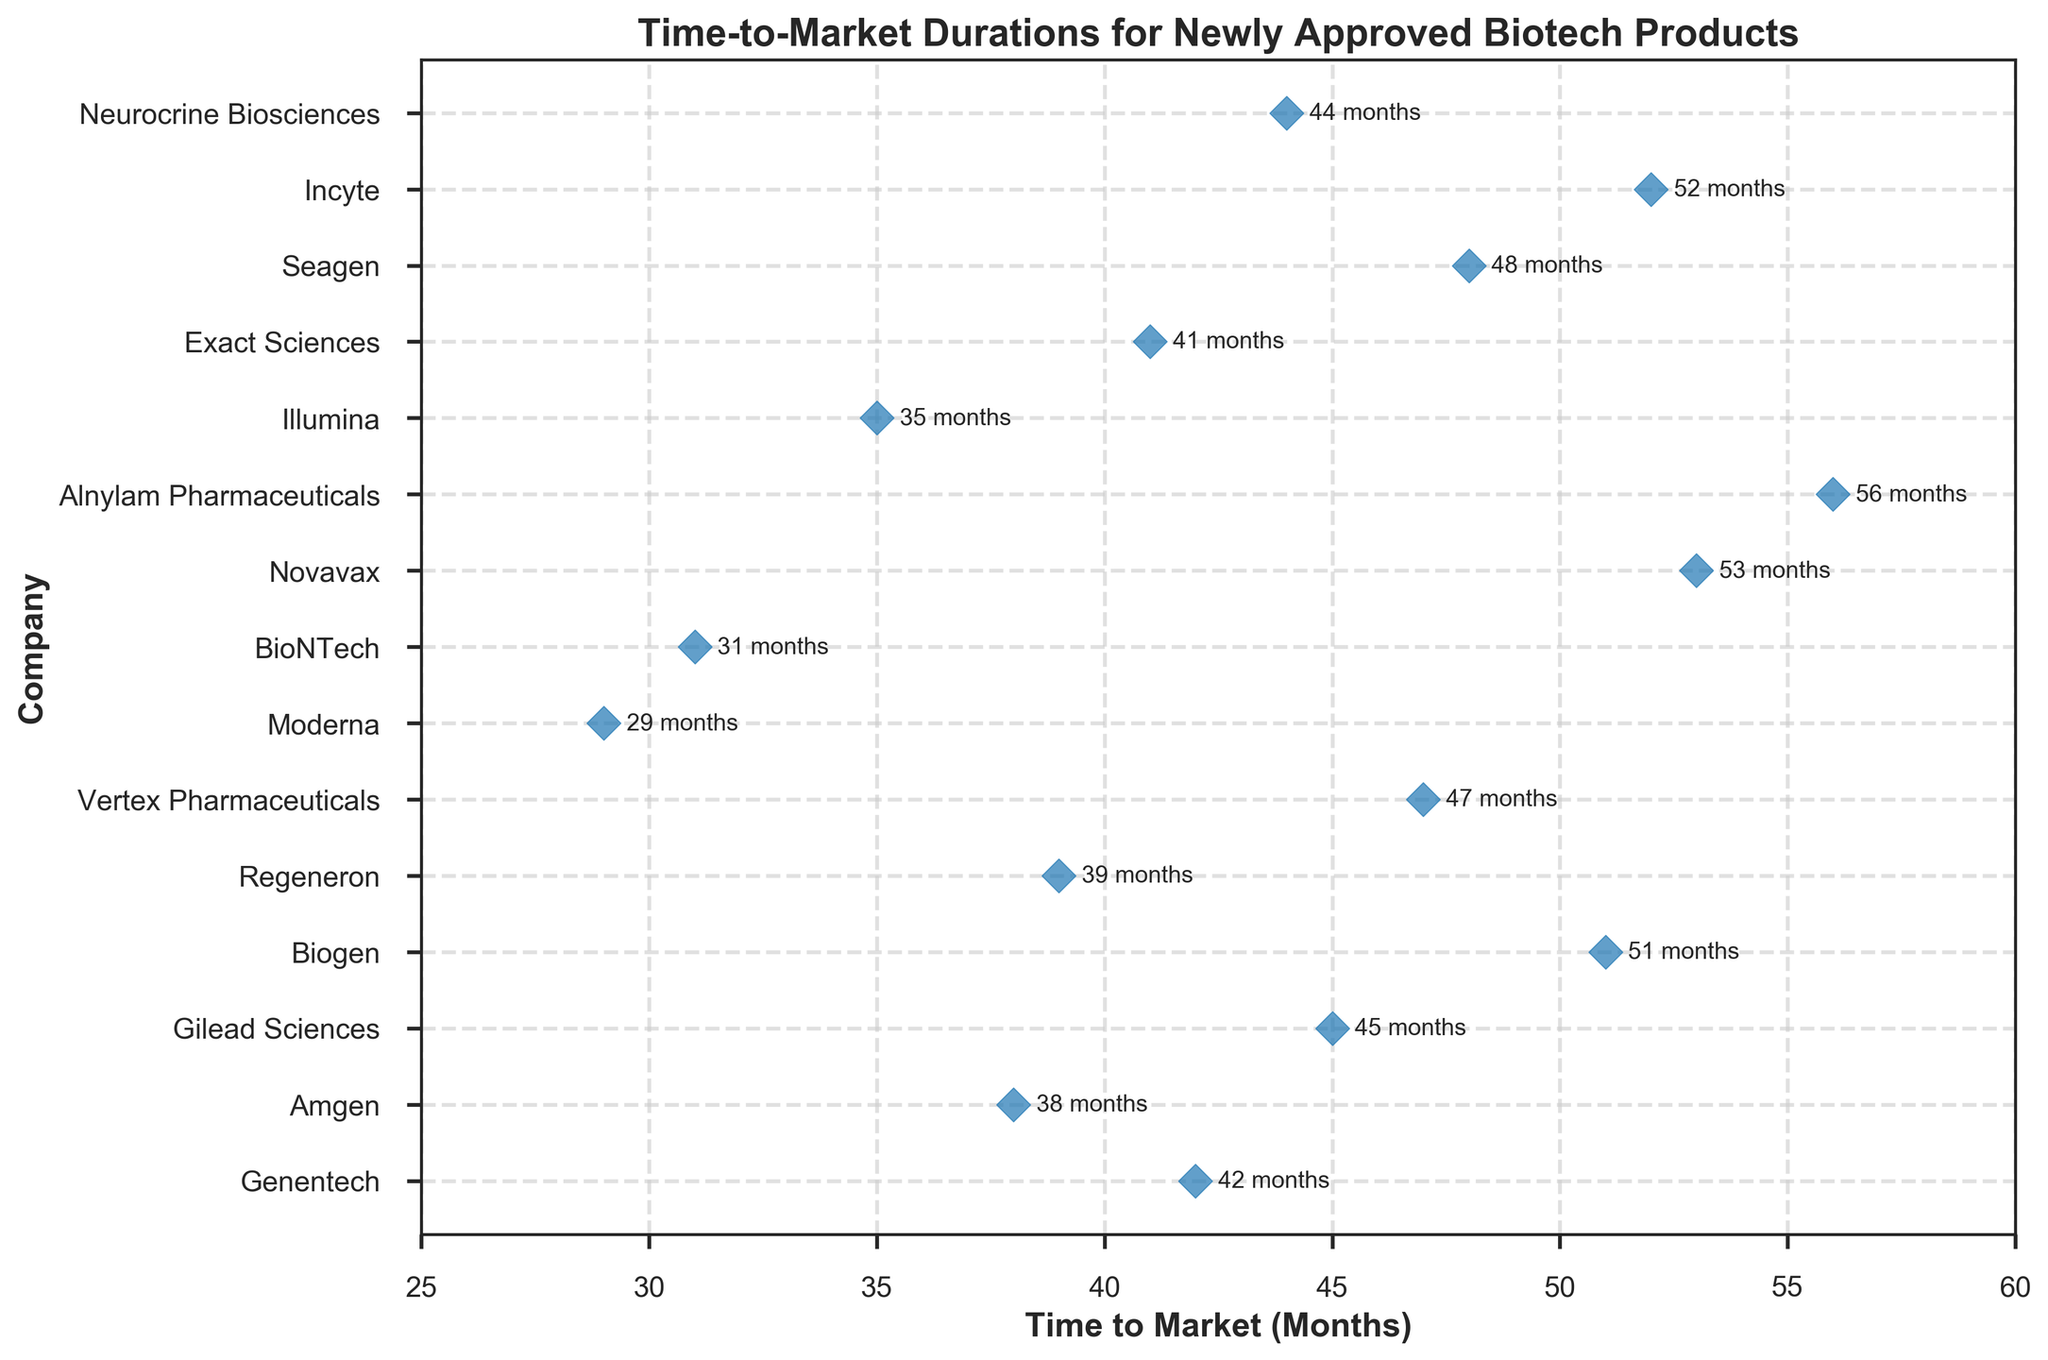What's the title of the plot? The title can be found at the top of the figure and usually highlights the main topic. In this case, it is written in bold at the center of the plot.
Answer: Time-to-Market Durations for Newly Approved Biotech Products Which company has the shortest time-to-market? Looking at the plot, identify the data point that is farthest to the left, as it represents the shortest duration in months. The company associated with this point is Moderna.
Answer: Moderna How many companies have a time-to-market duration of less than 40 months? Count the number of data points that fall to the left of the 40-month mark on the x-axis. There are four such points: Genentech, Amgen, Moderna, and BioNTech.
Answer: 4 What are the companies with a time-to-market duration of more than 50 months? Identify the data points that fall to the right of the 50-month mark on the x-axis. The companies associated with these points are Novavax, Alnylam Pharmaceuticals, and Incyte.
Answer: Novavax, Alnylam Pharmaceuticals, and Incyte What is the range of time-to-market durations among all companies? Find the difference between the maximum and minimum values on the x-axis. The minimum time-to-market is 29 months (Moderna) and the maximum is 56 months (Alnylam Pharmaceuticals), so the range is 56 - 29.
Answer: 27 months Which company is closest to the average time-to-market duration? First, find the average duration by summing all time intervals and dividing by the number of data points. (42 + 38 + 45 + 51 + 39 + 47 + 29 + 31 + 53 + 56 + 35 + 41 + 48 + 52 + 44) / 15 = 43.06 months. Identify the company closest to this average. Neurocrine Biosciences at 44 months is closest.
Answer: Neurocrine Biosciences Is there a significant clustering of time-to-market durations between any specific range? Observe the density of points between different ranges on the x-axis. There is a noticeable clustering between 38 to 48 months.
Answer: Yes, between 38 to 48 months How do the top three quickest companies compare to the top three slowest companies in terms of average time-to-market? Identify the three quickest (Moderna: 29, BioNTech: 31, Amgen: 38) and three slowest (Incyte: 52, Alnylam Pharmaceuticals: 56, Novavax: 53). Calculate their averages: 
Quickest: (29 + 31 + 38) / 3 = 32.67 months 
Slowest: (52 + 56 + 53) / 3 = 53.67 months
Answer: Quickest: 32.67 months, Slowest: 53.67 months 